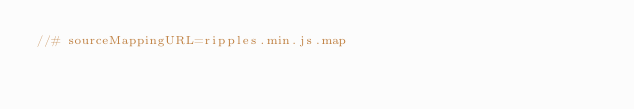<code> <loc_0><loc_0><loc_500><loc_500><_JavaScript_>//# sourceMappingURL=ripples.min.js.map
</code> 